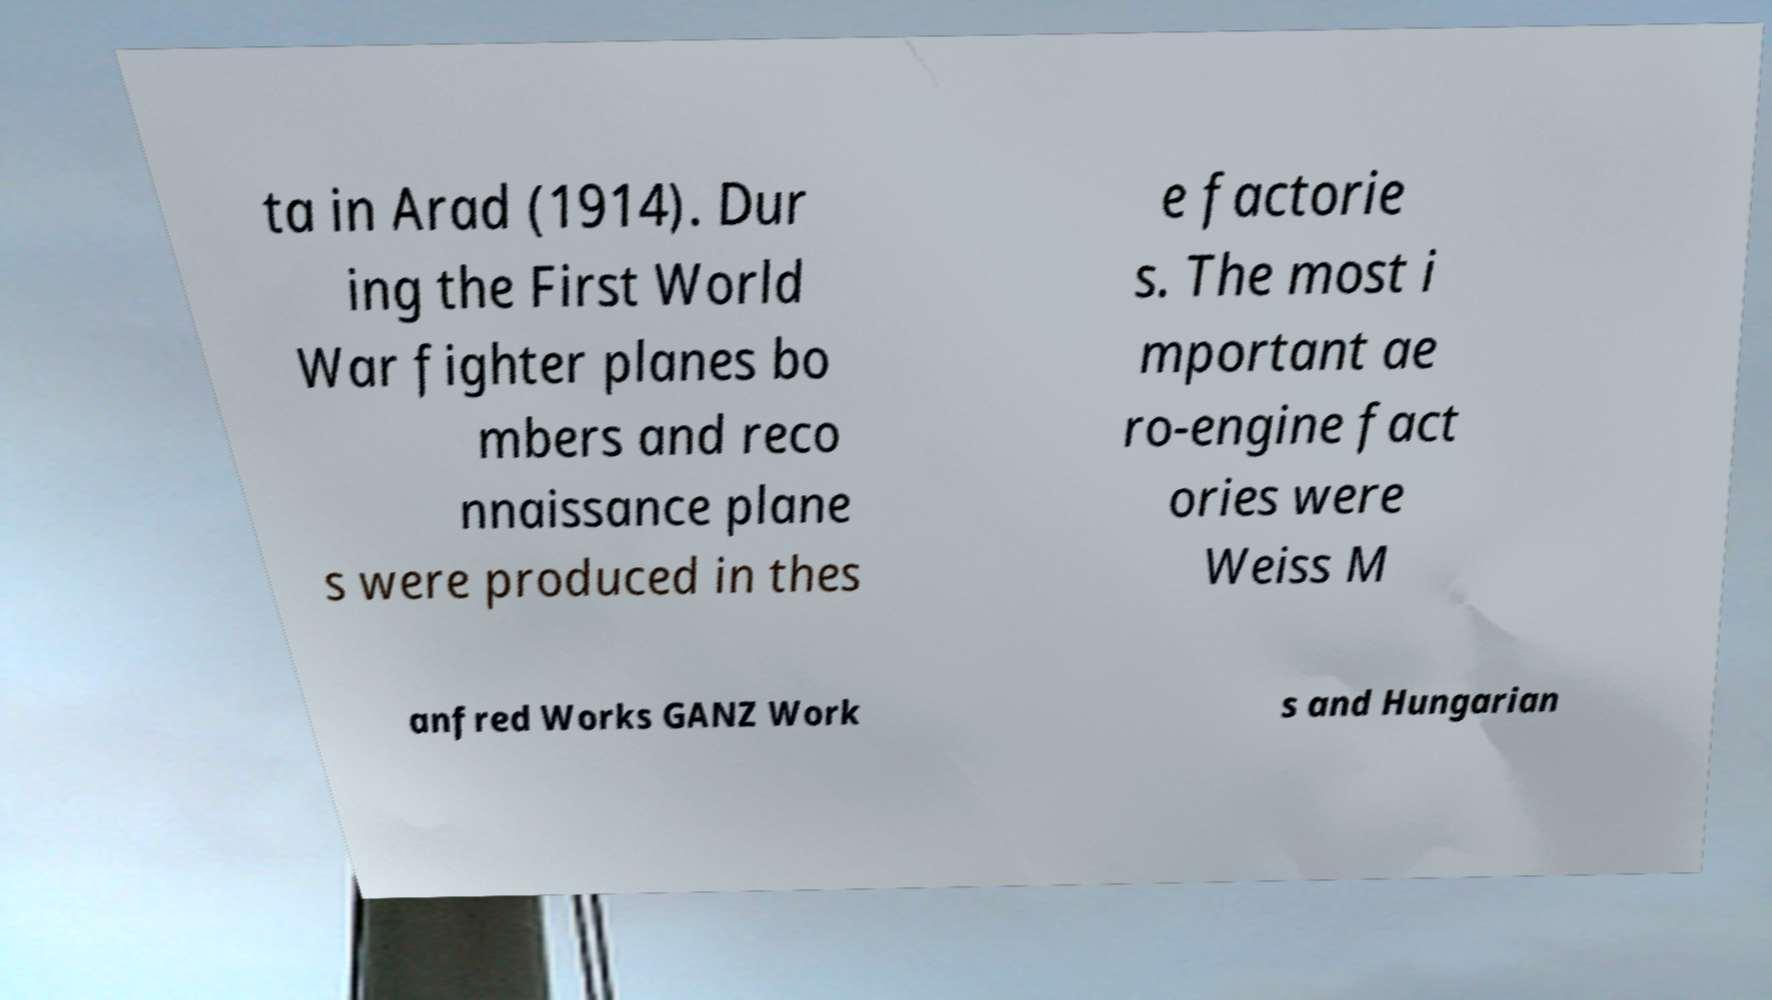Can you read and provide the text displayed in the image?This photo seems to have some interesting text. Can you extract and type it out for me? ta in Arad (1914). Dur ing the First World War fighter planes bo mbers and reco nnaissance plane s were produced in thes e factorie s. The most i mportant ae ro-engine fact ories were Weiss M anfred Works GANZ Work s and Hungarian 